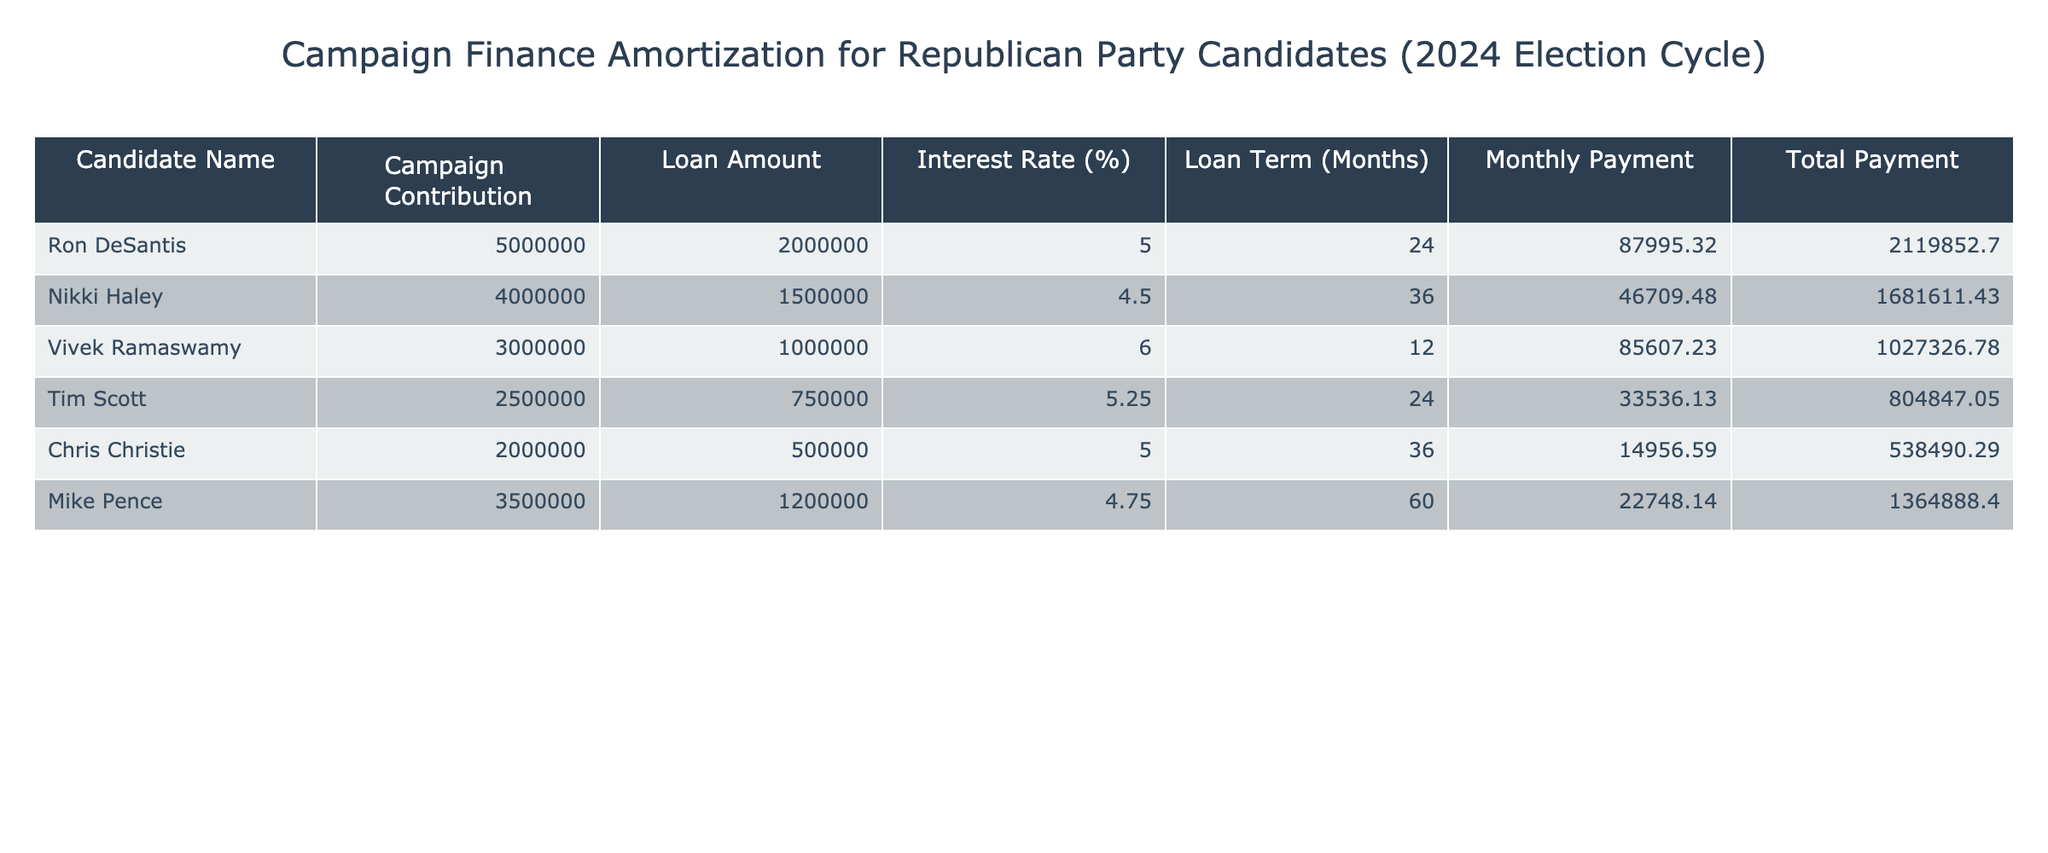What is the total payment amount made by Ron DeSantis? According to the table, Ron DeSantis has a total payment amount listed as 2,119,852.70.
Answer: 2,119,852.70 What is the monthly payment for Nikki Haley? The table indicates that Nikki Haley's monthly payment is 46,709.48.
Answer: 46,709.48 Which candidate has the highest loan amount? By comparing the loan amounts, Ron DeSantis has the highest loan amount of 2,000,000.
Answer: 2,000,000 What is the average interest rate for all candidates? To find the average, add all interest rates together: (5 + 4.5 + 6 + 5.25 + 5 + 4.75) = 31.5, then divide by 6, which gives 31.5 / 6 = 5.25.
Answer: 5.25 Did Mike Pence's total payment exceed that of Chris Christie? Mike Pence's total payment is 1,364,888.40 and Chris Christie's total payment is 538,490.29. Since 1,364,888.40 > 538,490.29? This statement is true.
Answer: Yes Which candidate has a loan term of 36 months? In the table, both Nikki Haley and Chris Christie have a loan term of 36 months.
Answer: Nikki Haley and Chris Christie What is the combined monthly payment of Tim Scott and Vivek Ramaswamy? Adding Tim Scott's monthly payment (33,536.13) and Vivek Ramaswamy's monthly payment (85,607.23) gives a total of 33,536.13 + 85,607.23 = 119,143.36.
Answer: 119,143.36 Is it true that all candidates have campaign contributions greater than 2 million? Looking at the campaign contributions, only Chris Christie (2,000,000) and Tim Scott (2,500,000) do not exceed 2 million. Thus, the statement is false.
Answer: No What candidate has the lowest monthly payment? Examining the monthly payments, Chris Christie has the lowest amount listed at 14,956.59.
Answer: 14,956.59 